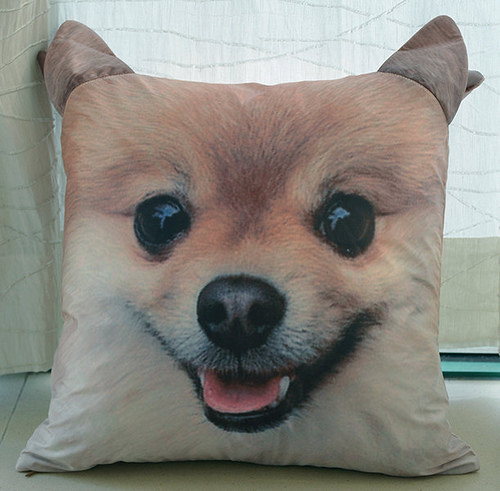<image>
Is the pillow behind the curtain? No. The pillow is not behind the curtain. From this viewpoint, the pillow appears to be positioned elsewhere in the scene. 